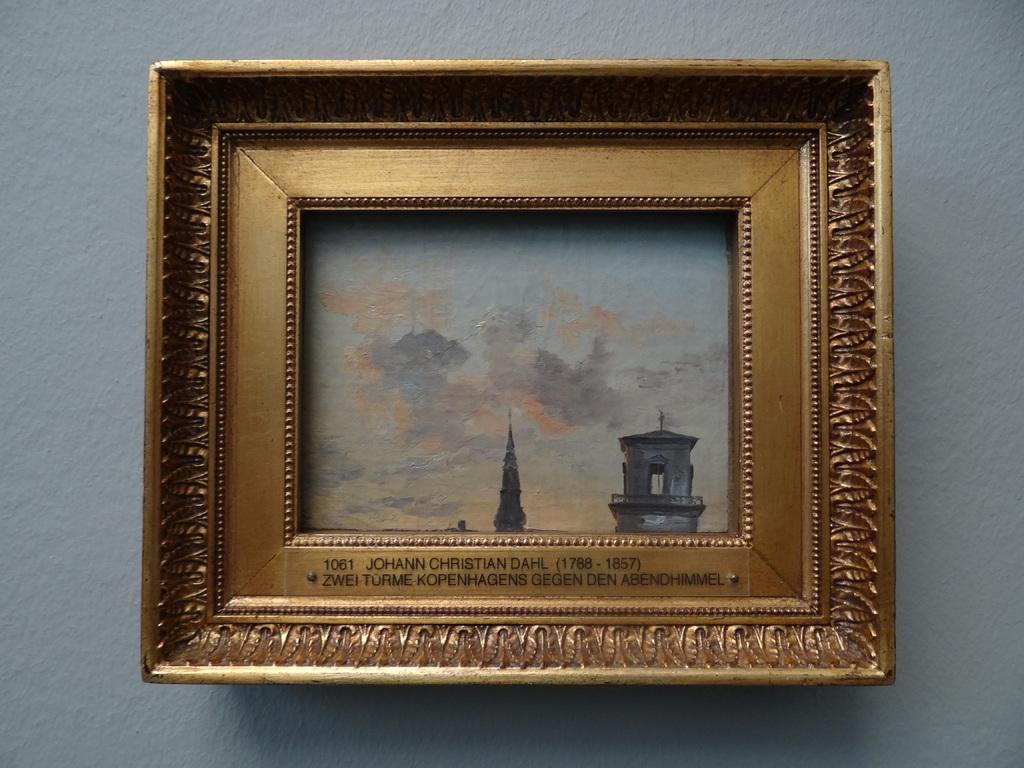<image>
Give a short and clear explanation of the subsequent image. the name Johann is on the frame with gold on it 